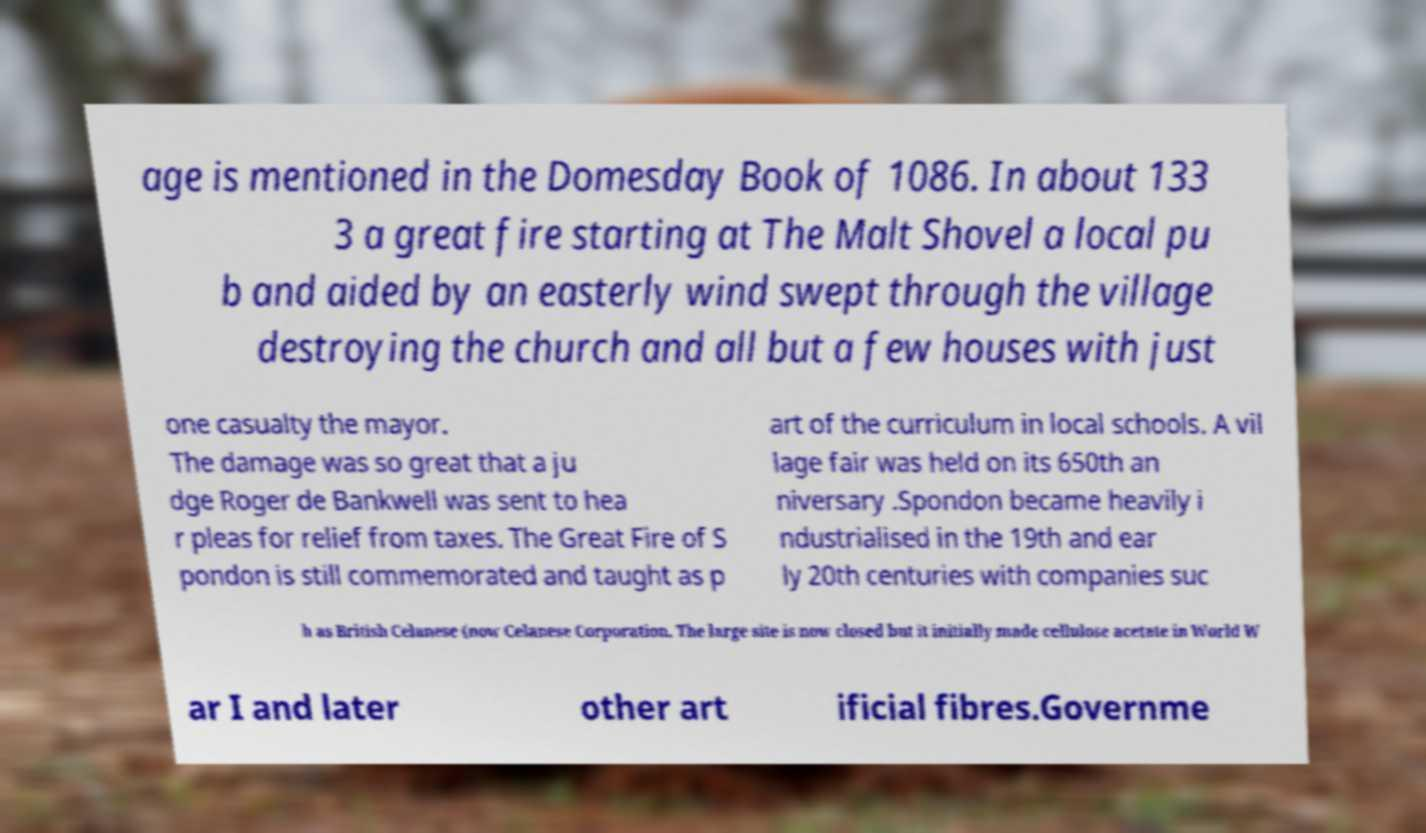There's text embedded in this image that I need extracted. Can you transcribe it verbatim? age is mentioned in the Domesday Book of 1086. In about 133 3 a great fire starting at The Malt Shovel a local pu b and aided by an easterly wind swept through the village destroying the church and all but a few houses with just one casualty the mayor. The damage was so great that a ju dge Roger de Bankwell was sent to hea r pleas for relief from taxes. The Great Fire of S pondon is still commemorated and taught as p art of the curriculum in local schools. A vil lage fair was held on its 650th an niversary .Spondon became heavily i ndustrialised in the 19th and ear ly 20th centuries with companies suc h as British Celanese (now Celanese Corporation. The large site is now closed but it initially made cellulose acetate in World W ar I and later other art ificial fibres.Governme 